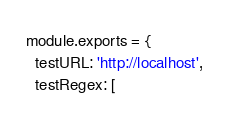Convert code to text. <code><loc_0><loc_0><loc_500><loc_500><_JavaScript_>module.exports = {
  testURL: 'http://localhost',
  testRegex: [</code> 